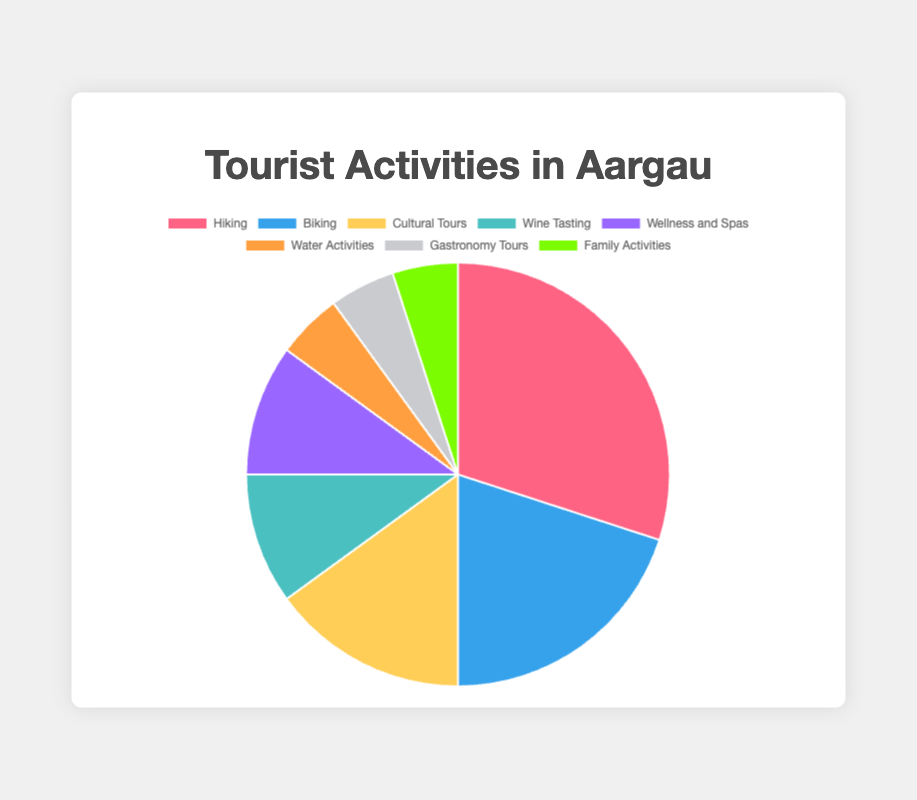What proportion of tourist activities in Aargau is dedicated to hiking? By looking at the pie chart, we can see that the segment for hiking occupies 30% of the total pie, indicating that 30% of the tourist activities in Aargau are dedicated to hiking.
Answer: 30% Which tourist activity has the smallest proportion in Aargau? The pie chart shows that Water Activities, Gastronomy Tours, and Family Activities each occupy the smallest segment, each representing 5% of the total pie chart.
Answer: Water Activities, Gastronomy Tours, and Family Activities How does the proportion of cultural tours compare to the combined proportion of wine tasting and wellness and spas? The pie chart shows that cultural tours occupy 15% of the pie. The proportions for wine tasting and wellness and spas are both 10%. Adding the two, wine tasting and wellness and spas together occupy 20%. Hence, cultural tours occupy a smaller proportion than the combined proportion of wine tasting and wellness and spas.
Answer: Smaller What is the difference in proportion between hiking and biking activities? From the pie chart, hiking occupies 30% of the pie, while biking occupies 20%. The difference is found by subtracting 20% from 30%, which equals 10%.
Answer: 10% What percent of the pie chart is represented by activities other than hiking? From the pie chart, hiking occupies 30%. To find the percent represented by other activities, subtract 30% from 100%, which equals 70%.
Answer: 70% Which color represents the “Wellness and Spas” category in the pie chart? By observing the pie chart, we see that the segment for Wellness and Spas is represented by a purple color.
Answer: Purple What is the combined proportion of activities related to tours (cultural tours and gastronomy tours)? From the pie chart, cultural tours make up 15%, and gastronomy tours make up 5%. Adding these together gives 15% + 5% = 20%.
Answer: 20% Which activity has a larger proportion: biking or wine tasting? Biking has a proportion of 20% in the pie chart, while wine tasting has a proportion of 10%. Therefore, biking has a larger proportion than wine tasting.
Answer: Biking What is the average proportion of the activities with the smallest percentage? Water Activities, Gastronomy Tours, and Family Activities each occupy 5%. To find the average proportion, add the proportions together and divide by the number of activities: (5% + 5% + 5%) / 3 = 15% / 3 = 5%.
Answer: 5% How much more popular is hiking compared to Wellness and Spas, in terms of percentage? Hiking represents 30% of the pie chart, while Wellness and Spas represent 10%. To find how much more popular hiking is, subtract 10% from 30%, which equals 20%.
Answer: 20% 